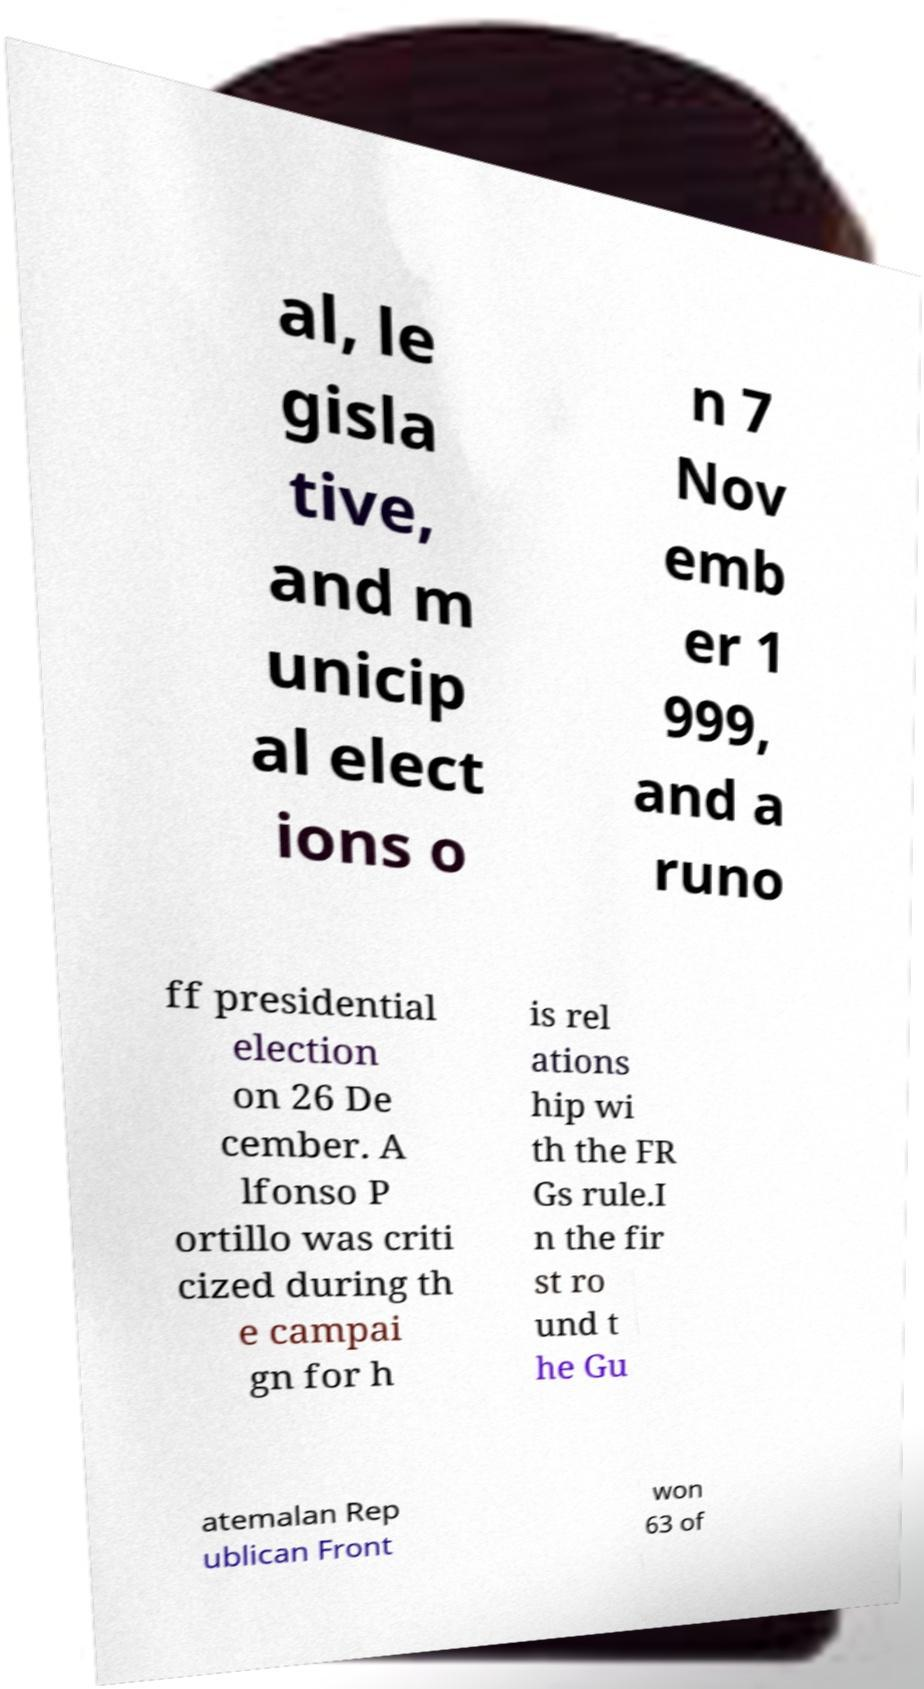Could you extract and type out the text from this image? al, le gisla tive, and m unicip al elect ions o n 7 Nov emb er 1 999, and a runo ff presidential election on 26 De cember. A lfonso P ortillo was criti cized during th e campai gn for h is rel ations hip wi th the FR Gs rule.I n the fir st ro und t he Gu atemalan Rep ublican Front won 63 of 